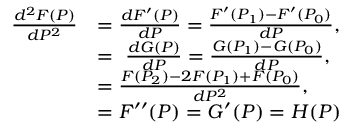Convert formula to latex. <formula><loc_0><loc_0><loc_500><loc_500>{ \begin{array} { r l } { { \frac { d ^ { 2 } F ( P ) } { d P ^ { 2 } } } } & { = { \frac { d F ^ { \prime } ( P ) } { d P } } = { \frac { F ^ { \prime } ( P _ { 1 } ) - F ^ { \prime } ( P _ { 0 } ) } { d P } } , } \\ & { = \ { \frac { d G ( P ) } { d P } } = { \frac { G ( P _ { 1 } ) - G ( P _ { 0 } ) } { d P } } , } \\ & { = { \frac { F ( P _ { 2 } ) - 2 F ( P _ { 1 } ) + F ( P _ { 0 } ) } { d P ^ { 2 } } } , } \\ & { = F ^ { \prime \prime } ( P ) = G ^ { \prime } ( P ) = H ( P ) } \end{array} }</formula> 